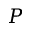<formula> <loc_0><loc_0><loc_500><loc_500>P</formula> 